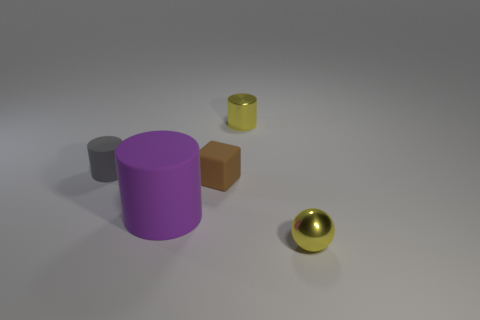Subtract all purple rubber cylinders. How many cylinders are left? 2 Subtract all gray cylinders. How many cylinders are left? 2 Add 5 tiny cyan cylinders. How many objects exist? 10 Subtract all cubes. How many objects are left? 4 Subtract 1 blocks. How many blocks are left? 0 Add 1 tiny cubes. How many tiny cubes are left? 2 Add 2 gray matte objects. How many gray matte objects exist? 3 Subtract 0 gray cubes. How many objects are left? 5 Subtract all red cylinders. Subtract all red balls. How many cylinders are left? 3 Subtract all tiny brown rubber cylinders. Subtract all matte cylinders. How many objects are left? 3 